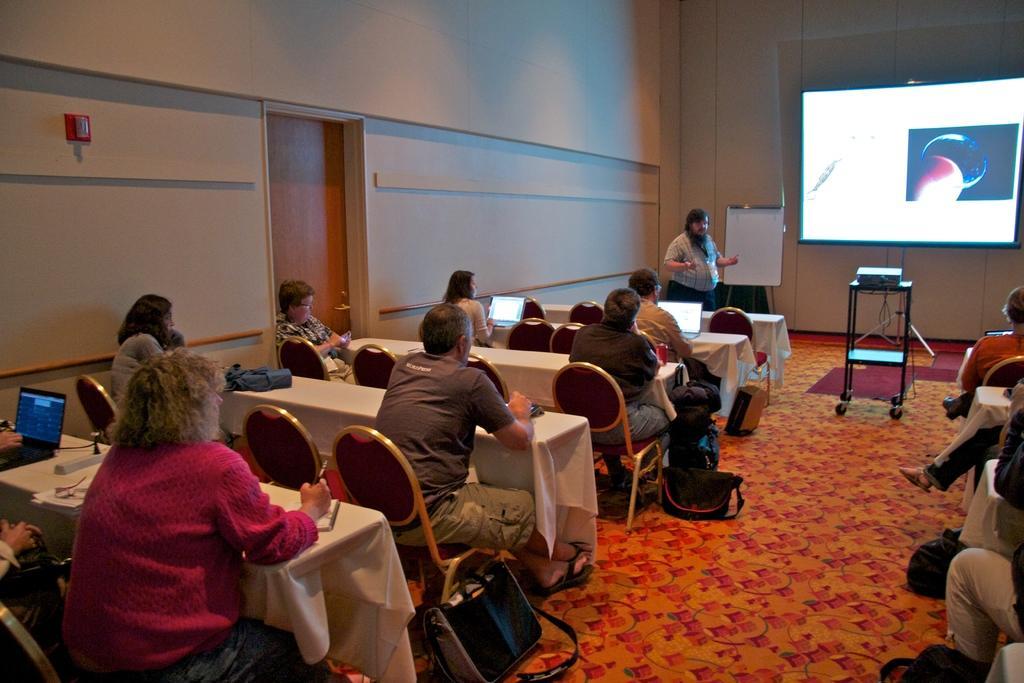Describe this image in one or two sentences. In this image I can see people where one is standing and rest all are sitting on chairs. I can also see few tables and on these tables I can see few laptops. Here I can see a projector's screen, projector and few bags. 